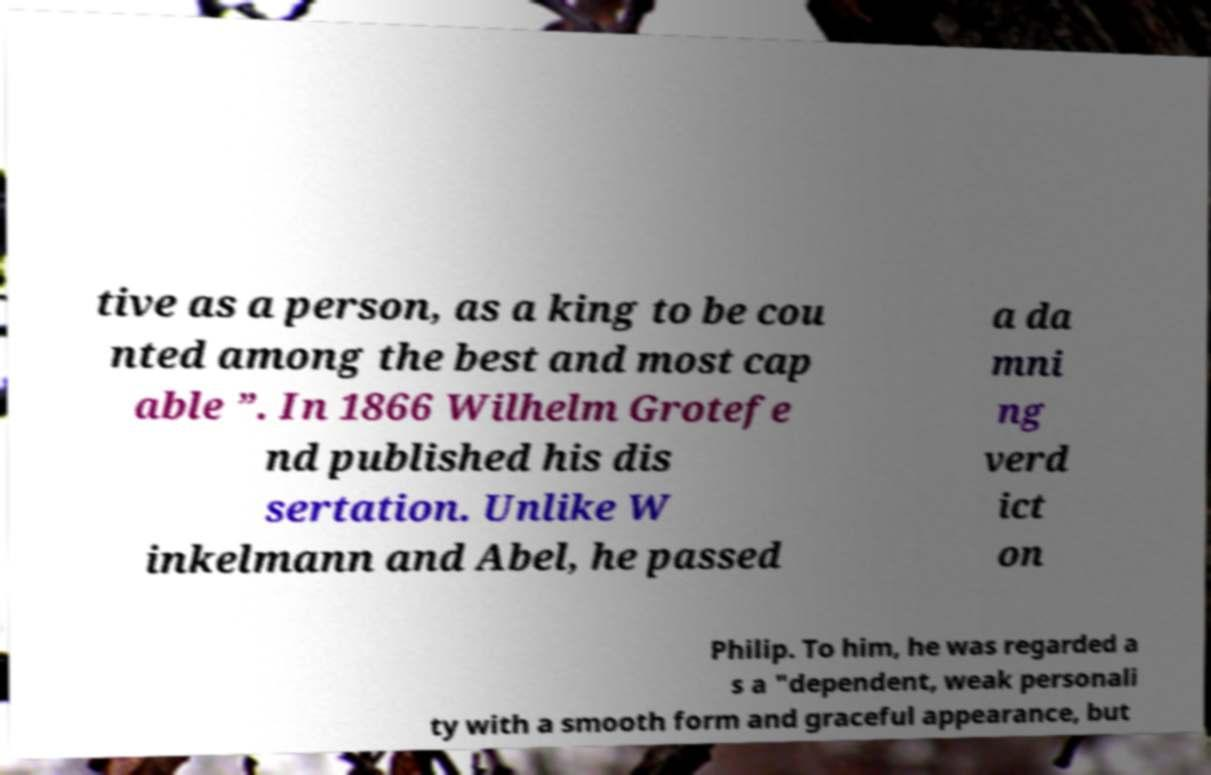For documentation purposes, I need the text within this image transcribed. Could you provide that? tive as a person, as a king to be cou nted among the best and most cap able ”. In 1866 Wilhelm Grotefe nd published his dis sertation. Unlike W inkelmann and Abel, he passed a da mni ng verd ict on Philip. To him, he was regarded a s a "dependent, weak personali ty with a smooth form and graceful appearance, but 